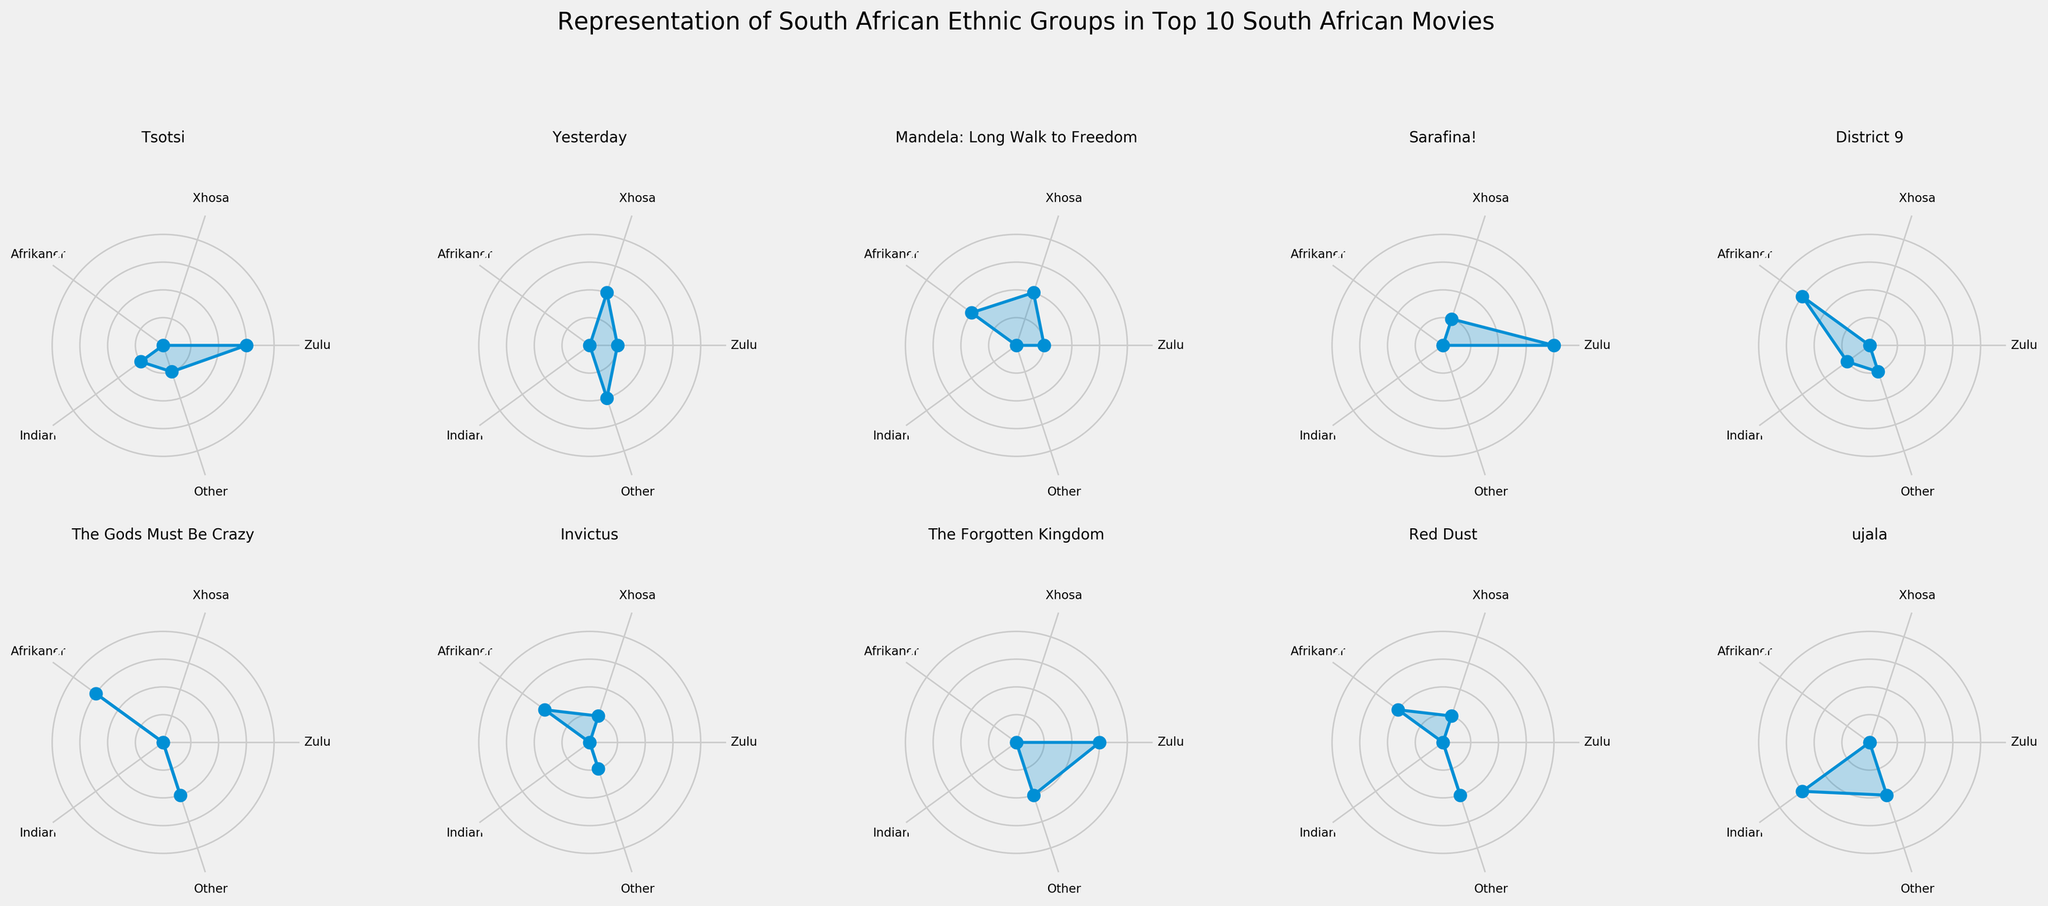What is the title of the figure? The title is usually located at the top of the figure and indicates the overall topic of the data being visualized. Here, it clearly describes the central theme of the radar chart subplots.
Answer: Representation of South African Ethnic Groups in Top 10 South African Movies How many movies are visualized in the radar charts? This can be determined by counting the number of subplot titles which correspond to the movie names.
Answer: 10 Which movie has the highest representation of Zulu characters in a leading role? By examining the leading role subplots, identify the one with the highest value for Zulu characters. "Tsotsi" and "The Forgotten Kingdom" both feature Zulu characters in leading roles with a high value.
Answer: Tsotsi and The Forgotten Kingdom For which movie do Afrikaner characters appear in the highest number of supporting roles? Review each subplot for supporting roles to see where the Afrikaner category is maximized; the movie with the highest value will be the answer.
Answer: District 9 What is the sum of values for Xhosa representation in lead roles across all movies? Sum the Xhosa values from each subplot that represents a lead role. For Mandela: Long Walk to Freedom (2), Invictus (1), and Yesterday (2).
Answer: 5 Which movie shows an equal representation of both Indian and Other ethnic groups? Look for subplots where the values for Indian and Other categories are the same. In "ujala," both categories are represented equally with values of 3 (Indian) and 2 (Other).
Answer: ujala In "The Gods Must Be Crazy," which ethnic group has the highest representation? Observe the values in the radar chart for "The Gods Must Be Crazy" to identify the highest value among the ethnic groups. The Afrikaner group has the highest representation.
Answer: Afrikaner Are there any movies where an ethnic group has no representation at all? Which movie and group? Examine each subplot for any ethnic group that has a value of zero. For example, "Yesterday" has zero representation for Afrikaner, Indian, and Zulu in lead roles.
Answer: Yesterday, Afrikaner/Indian/Zulu Which movie has the most balanced representation across Zulu, Xhosa, Afrikaner, Indian, and Other categories? Check the radar charts for a movie where the values are closest to each other across all categories. "Mandela: Long Walk to Freedom" shows a balanced representation between Zulu (1), Xhosa (2), Afrikaner (2), and Other (0).
Answer: Mandela: Long Walk to Freedom 